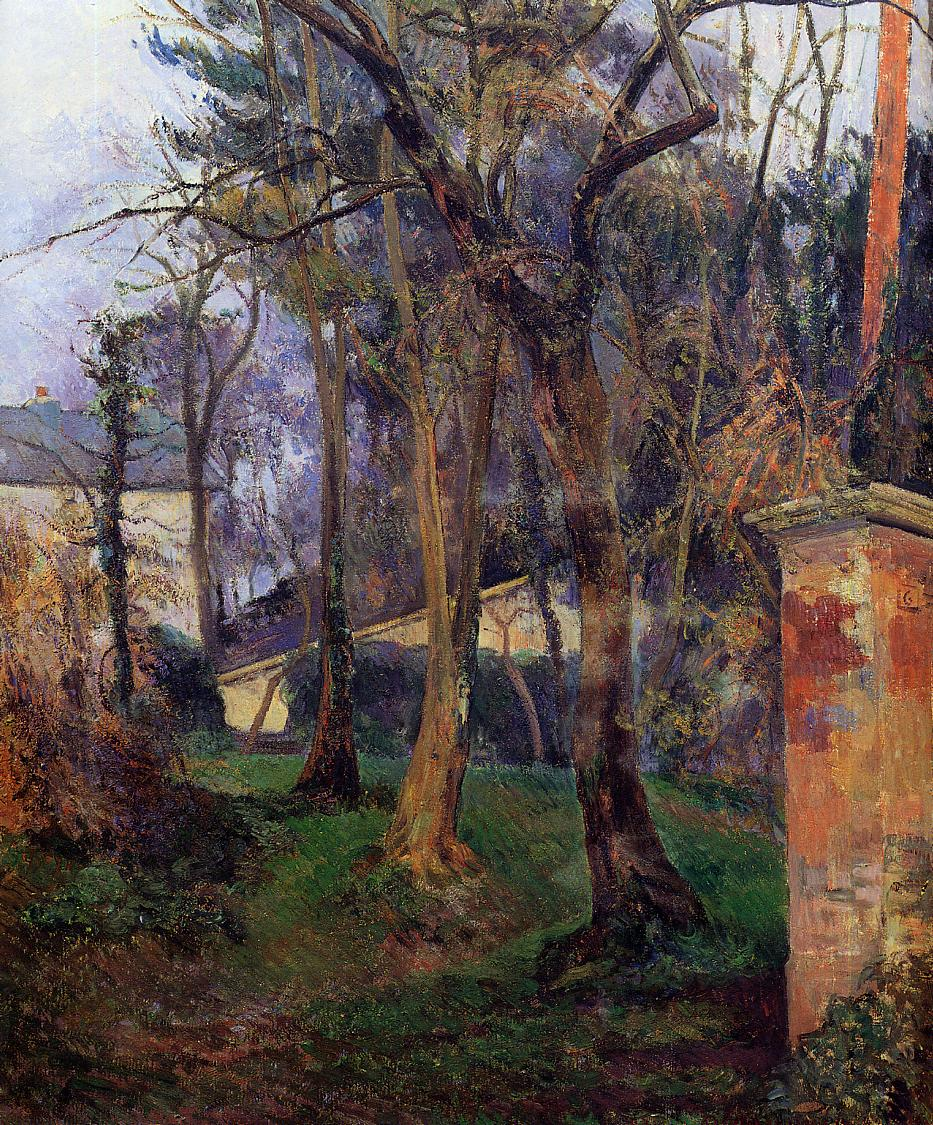What are the key elements in this picture? The image is an evocative impressionist painting that captures a verdant garden scene. The dominant colors, mainly shades of green, blue, and brown, blend to create a soothing visual palette that reflects the natural beauty of the landscape. This painting employs characteristic loose, brushy strokes of impressionism, which emphasize the interplay of light and shadow, enhancing the overall atmospheric depth. At the core of the garden, tall trees with intricately twisted trunks extend towards a softly painted sky, further framed by the vivid greens of dense foliage. In the background, a quaint house covered partially by the thick boughs adds a human element to the composition, reminding the viewer of the painter's keen sense of integrating architecture with nature. The image, filled with dynamic contrasts and a rich tapestry of textures, is a fine example of how impressionist art captures more than just the visual semblance of a scene but also its ephemeral, transient quality. 